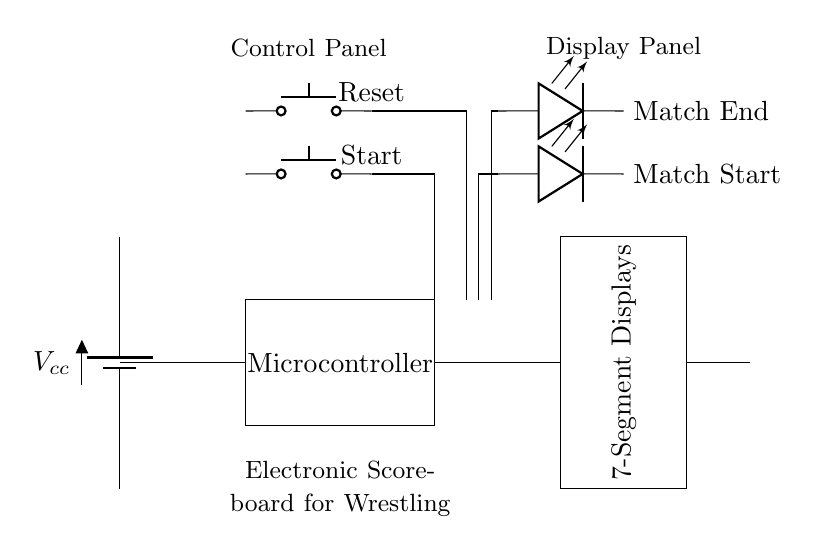What is the main power supply component? The main power supply component is a battery, which provides the required voltage for the electronic scoreboard circuit.
Answer: Battery How many push buttons are in the circuit? There are two push buttons in the circuit, labeled as Start and Reset, allowing user interaction for controlling the scoreboard.
Answer: Two What do the LED indicators represent? The LED indicators represent the states of the match; specifically, "Match Start" shows the beginning of the match, and "Match End" indicates the end of the match.
Answer: Match Start and Match End What is the function of the microcontroller? The microcontroller is the brains of the scoreboard, responsible for processing the inputs from the buttons and controlling the display outputs accordingly.
Answer: Processing inputs How is the buzzer connected in the circuit? The buzzer is connected to the same power line as the microcontroller, completing a path that allows it to activate when signaled by the microcontroller.
Answer: Through the microcontroller How do the buttons affect the scoreboard? The buttons provide user input to control the scoreboard, where the Start button initiates the scoring and the Reset button clears the scores as needed.
Answer: Control scoring and reset scores 